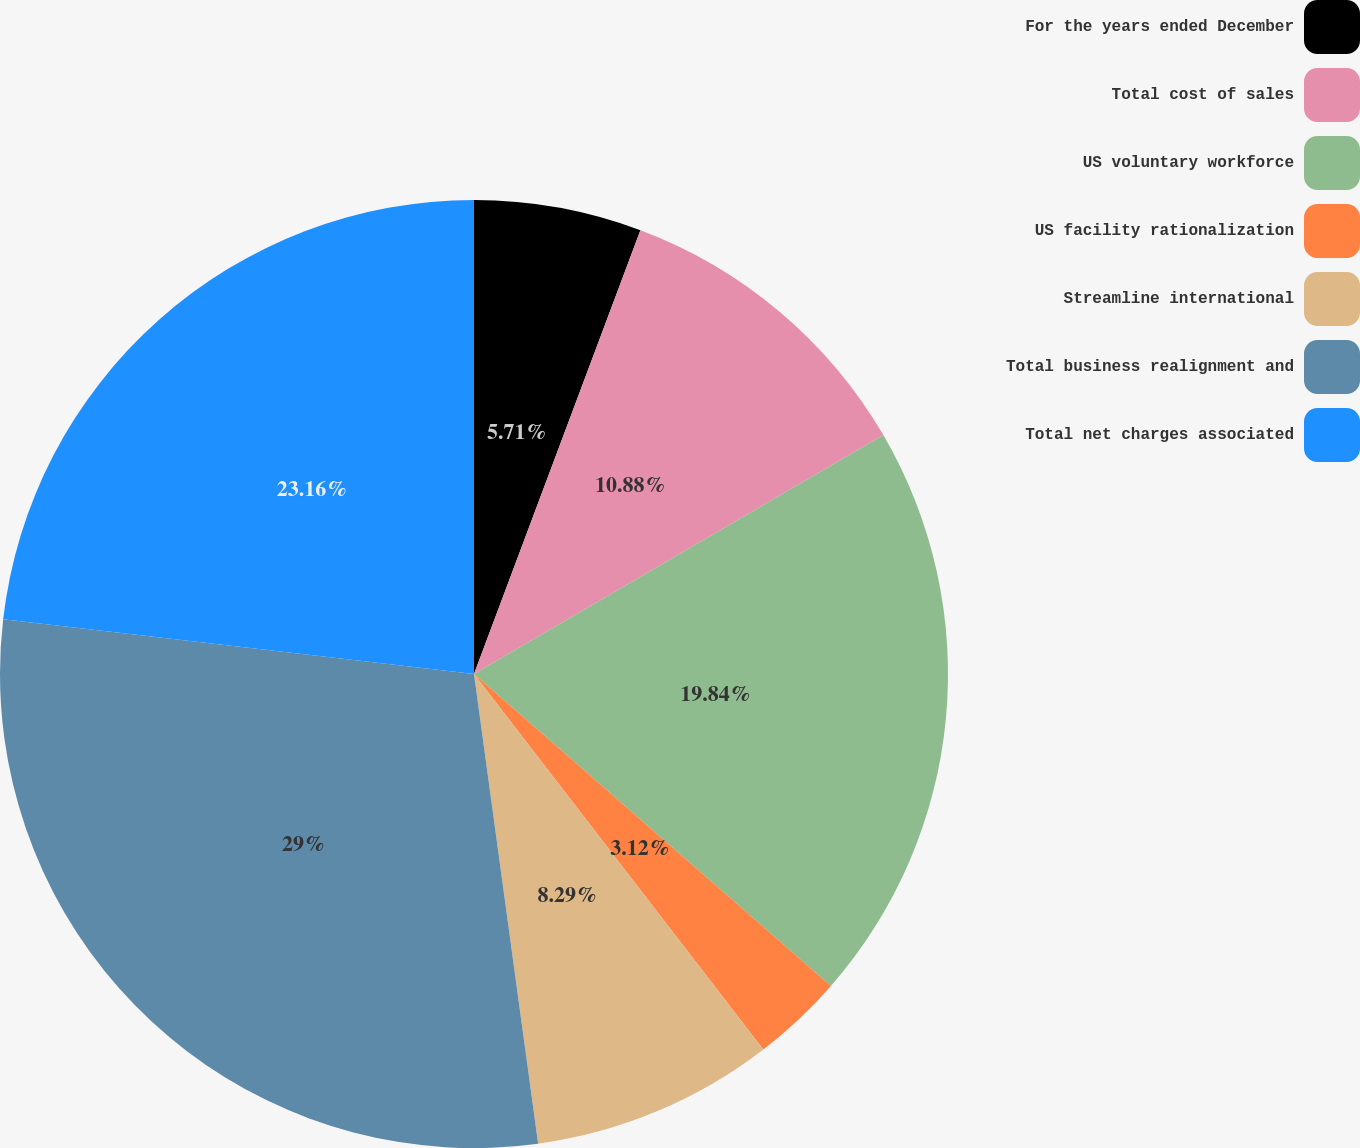Convert chart. <chart><loc_0><loc_0><loc_500><loc_500><pie_chart><fcel>For the years ended December<fcel>Total cost of sales<fcel>US voluntary workforce<fcel>US facility rationalization<fcel>Streamline international<fcel>Total business realignment and<fcel>Total net charges associated<nl><fcel>5.71%<fcel>10.88%<fcel>19.84%<fcel>3.12%<fcel>8.29%<fcel>29.0%<fcel>23.16%<nl></chart> 